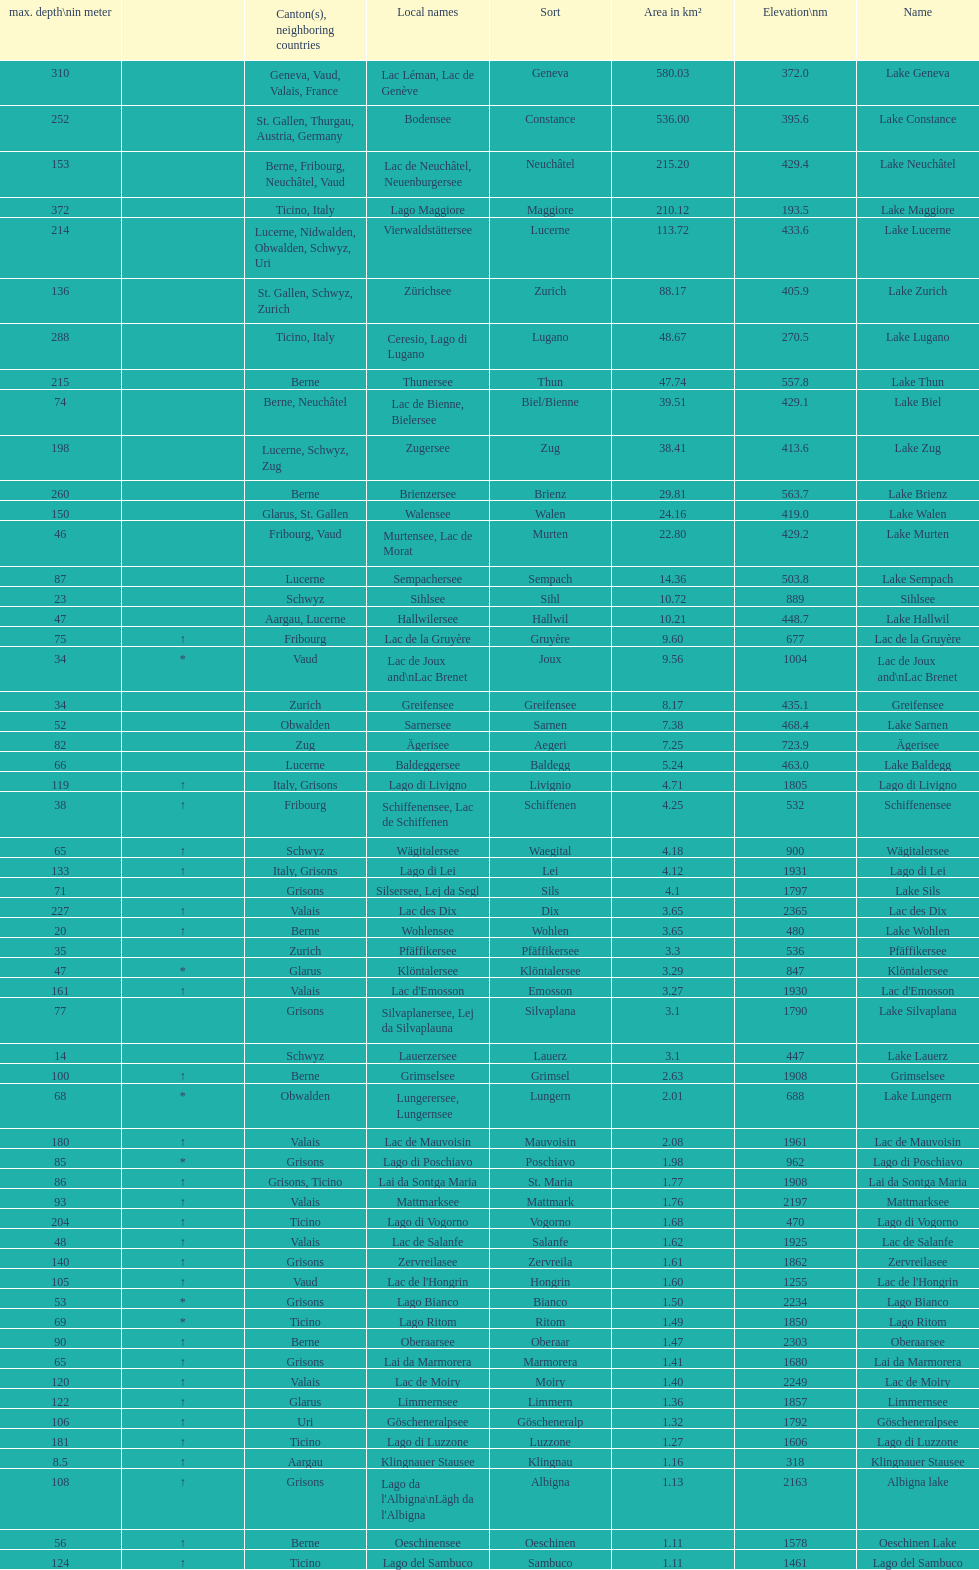Which lake has the greatest elevation? Lac des Dix. 